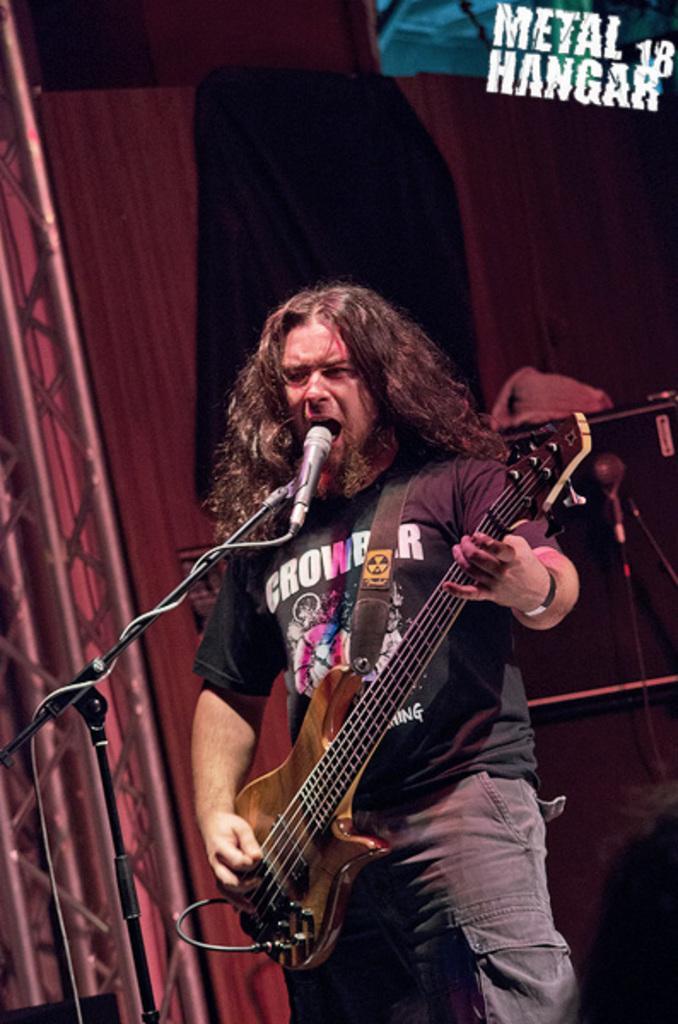Describe this image in one or two sentences. A man is standing holding a guitar and singing in a micro phone. At the back ground i can see a wooden door and a curtain. 